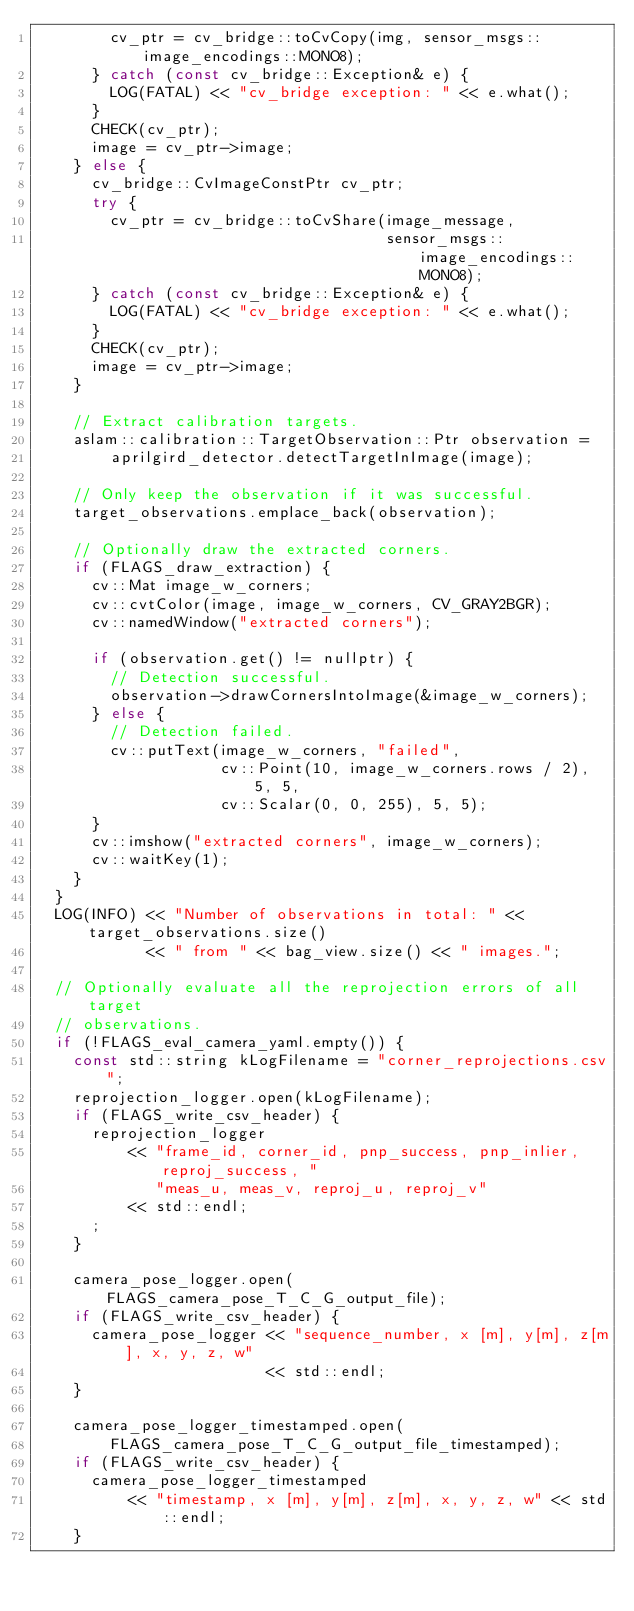<code> <loc_0><loc_0><loc_500><loc_500><_C++_>        cv_ptr = cv_bridge::toCvCopy(img, sensor_msgs::image_encodings::MONO8);
      } catch (const cv_bridge::Exception& e) {
        LOG(FATAL) << "cv_bridge exception: " << e.what();
      }
      CHECK(cv_ptr);
      image = cv_ptr->image;
    } else {
      cv_bridge::CvImageConstPtr cv_ptr;
      try {
        cv_ptr = cv_bridge::toCvShare(image_message,
                                      sensor_msgs::image_encodings::MONO8);
      } catch (const cv_bridge::Exception& e) {
        LOG(FATAL) << "cv_bridge exception: " << e.what();
      }
      CHECK(cv_ptr);
      image = cv_ptr->image;
    }

    // Extract calibration targets.
    aslam::calibration::TargetObservation::Ptr observation =
        aprilgird_detector.detectTargetInImage(image);

    // Only keep the observation if it was successful.
    target_observations.emplace_back(observation);

    // Optionally draw the extracted corners.
    if (FLAGS_draw_extraction) {
      cv::Mat image_w_corners;
      cv::cvtColor(image, image_w_corners, CV_GRAY2BGR);
      cv::namedWindow("extracted corners");

      if (observation.get() != nullptr) {
        // Detection successful.
        observation->drawCornersIntoImage(&image_w_corners);
      } else {
        // Detection failed.
        cv::putText(image_w_corners, "failed",
                    cv::Point(10, image_w_corners.rows / 2), 5, 5,
                    cv::Scalar(0, 0, 255), 5, 5);
      }
      cv::imshow("extracted corners", image_w_corners);
      cv::waitKey(1);
    }
  }
  LOG(INFO) << "Number of observations in total: " << target_observations.size()
            << " from " << bag_view.size() << " images.";

  // Optionally evaluate all the reprojection errors of all target
  // observations.
  if (!FLAGS_eval_camera_yaml.empty()) {
    const std::string kLogFilename = "corner_reprojections.csv";
    reprojection_logger.open(kLogFilename);
    if (FLAGS_write_csv_header) {
      reprojection_logger
          << "frame_id, corner_id, pnp_success, pnp_inlier, reproj_success, "
             "meas_u, meas_v, reproj_u, reproj_v"
          << std::endl;
      ;
    }

    camera_pose_logger.open(FLAGS_camera_pose_T_C_G_output_file);
    if (FLAGS_write_csv_header) {
      camera_pose_logger << "sequence_number, x [m], y[m], z[m], x, y, z, w"
                         << std::endl;
    }

    camera_pose_logger_timestamped.open(
        FLAGS_camera_pose_T_C_G_output_file_timestamped);
    if (FLAGS_write_csv_header) {
      camera_pose_logger_timestamped
          << "timestamp, x [m], y[m], z[m], x, y, z, w" << std::endl;
    }
</code> 